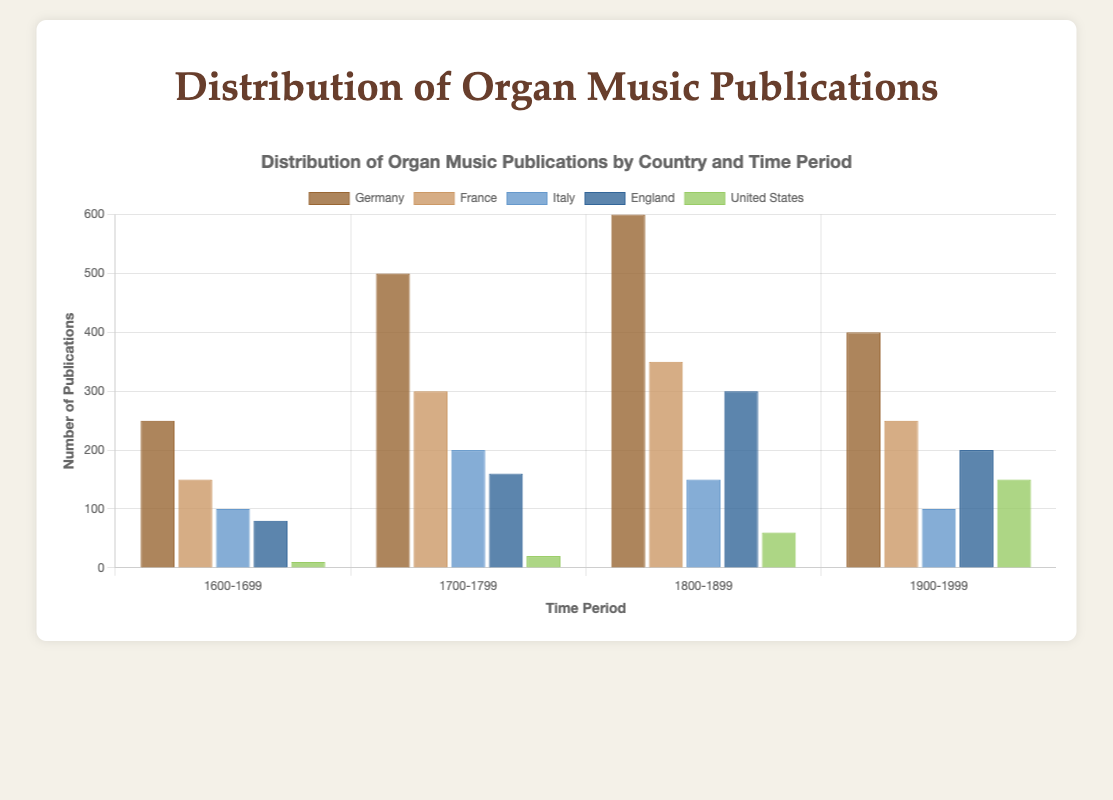How do the publications from Germany in the 1800-1899 period compare to those in the United States in the same period? To compare the publications from Germany and the United States in the period 1800-1899, locate the corresponding bars for both countries. Germany has 600 publications, and the United States has 60 publications. Thus, Germany has significantly more publications than the United States.
Answer: Germany has more What is the sum of publications in Italy from 1600 to 1899? To find the sum, locate the bars representing Italy in the periods 1600-1699, 1700-1799, and 1800-1899. Italy has 100, 200, and 150 publications respectively. The sum is 100 + 200 + 150 = 450
Answer: 450 Which country had the highest number of publications in the 1700-1799 period? Observe the bars for all countries in the period 1700-1799. Germany has the highest bar with 500 publications.
Answer: Germany Did France's publications increase or decrease from the 1800-1899 to the 1900-1999 period? Compare the bars for France in the 1800-1899 and 1900-1999 periods. The number of publications decreased from 350 to 250.
Answer: Decrease Which time period had the lowest number of publications in the United States? Look at all the bars for the United States across different periods. The period 1600-1699 has the lowest number of publications with just 10.
Answer: 1600-1699 What is the average number of publications in Germany across all time periods? Sum the number of publications in Germany for all periods: 250 + 500 + 600 + 400. The total is 1750. There are 4 periods, so the average is 1750/4 = 437.5
Answer: 437.5 How much higher are the publications in France compared to England in the 1700-1799 period? Locate the bars for France and England in the 1700-1799 period. France has 300 publications and England has 160. The difference is 300 - 160 = 140
Answer: 140 higher What is the total number of publications across all countries in the period 1900-1999? Add up the number of publications in the 1900-1999 period for Germany (400), France (250), Italy (100), England (200), and the United States (150). The sum is 400 + 250 + 100 + 200 + 150 = 1100
Answer: 1100 In which period did Italy have a publication number equal to or less than 150? Check the bars for Italy in each period. Italy had 100 publications in 1600-1699 and 1900-1999, and 150 publications in 1800-1899, all of which are equal to or less than 150.
Answer: 1600-1699, 1800-1899, 1900-1999 